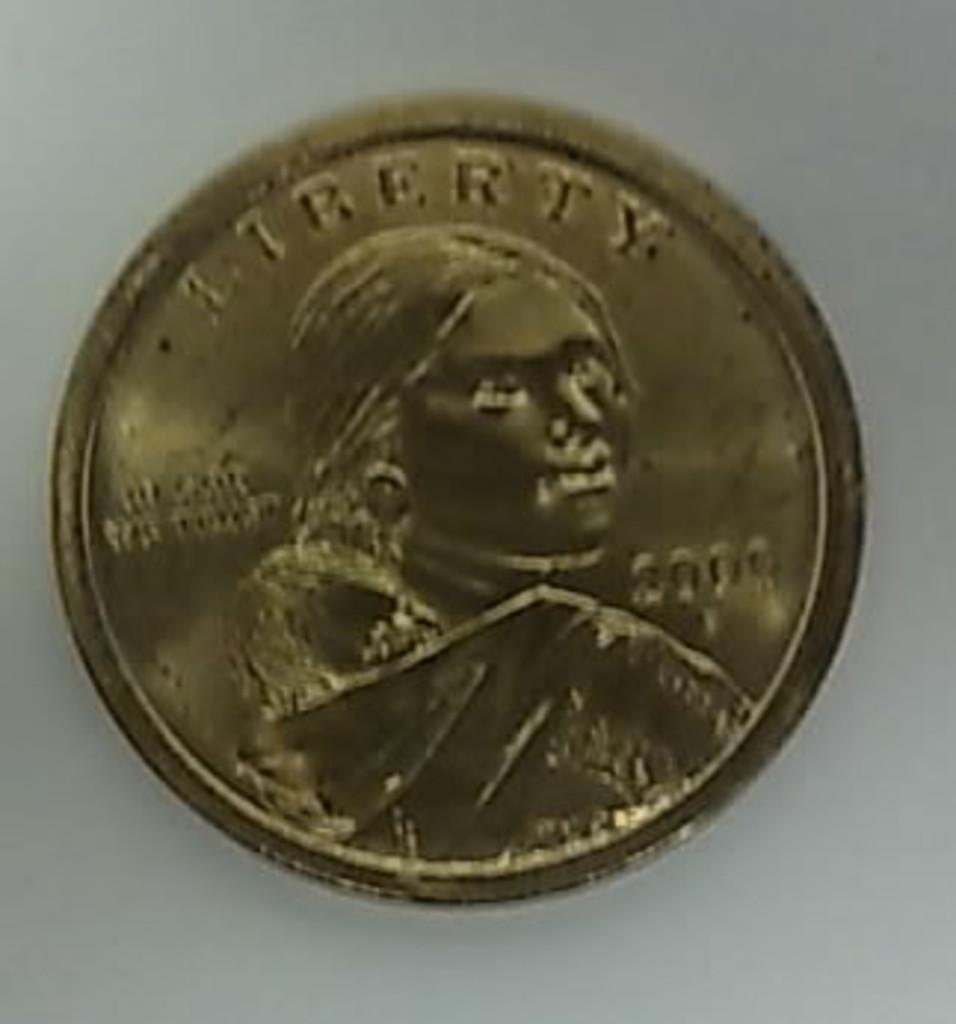<image>
Describe the image concisely. Copper coin with the word Liberty on the top. 